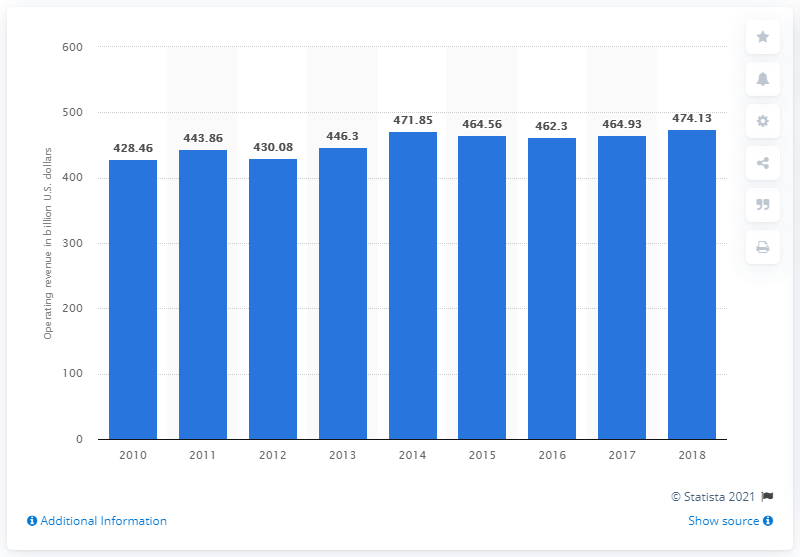Specify some key components in this picture. In 2018, the total operating revenue of the electric power sector was 474.13. 